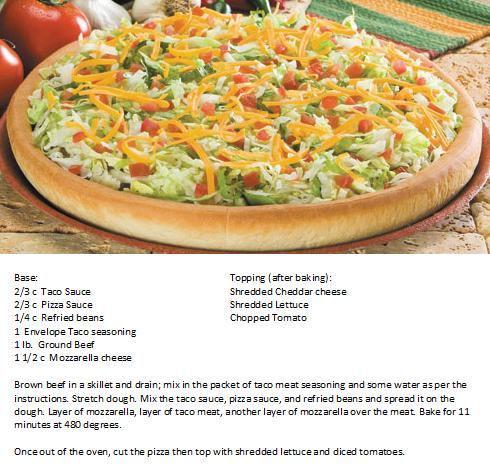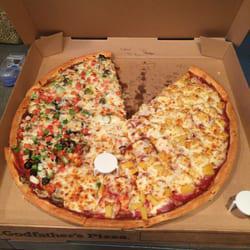The first image is the image on the left, the second image is the image on the right. Given the left and right images, does the statement "One of the pizzas is placed next to some fresh uncut tomatoes." hold true? Answer yes or no. Yes. The first image is the image on the left, the second image is the image on the right. Analyze the images presented: Is the assertion "There is one whole pizza in the right image." valid? Answer yes or no. No. 